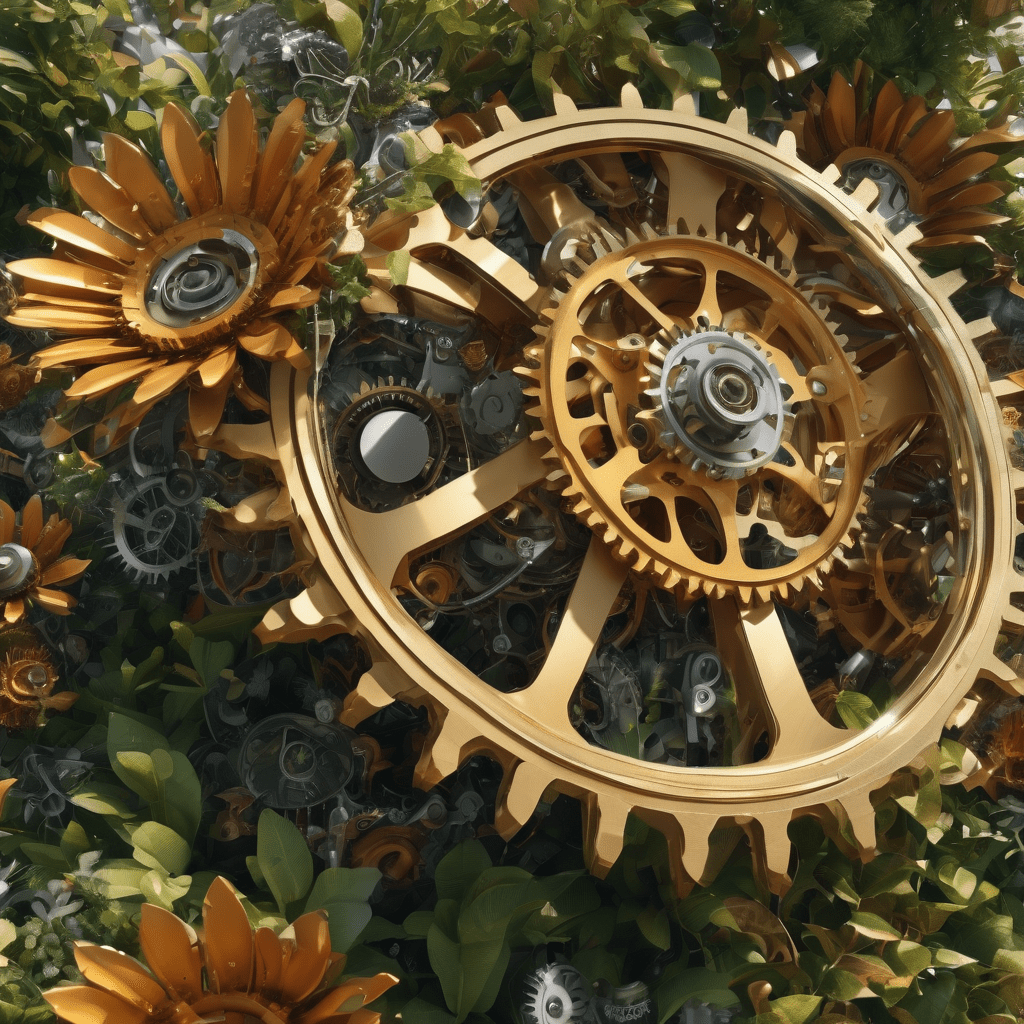What style of clothes does the person on the right sell ? The person on the right appears to be a salesperson or store clerk interacting with the customers, who seem to be looking at clothing items in the store. Based on the red and plaid patterned shirts hanging on the racks, the store likely sells casual clothing styles like button-up shirts, flannels or similar garments. What is this art style?
 The art style depicted in the image appears to be steampunk. Steampunk is a subgenre of science fiction that incorporates technology and aesthetic designs inspired by 19th-century industrial steam-powered machinery.

The intricate gold gears, cogs and mechanical elements arranged in a circular pattern are hallmark design features associated with the steampunk aesthetic. The gears are set against a lush background of leaves and flowers, creating an interesting juxtaposition of industrial machinery and natural elements that is often seen in steampunk artwork.

The warm, metallic tones of the gears contrasted with the vibrant greens of the foliage further reinforces the blend of technology and nature that characterizes this distinctive art style. Overall, the ornate mechanical details combined with the Victorian-era inspired floral motifs make this a striking example of steampunk design. 